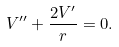Convert formula to latex. <formula><loc_0><loc_0><loc_500><loc_500>V ^ { \prime \prime } + \frac { 2 V ^ { \prime } } { r } = 0 .</formula> 